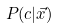Convert formula to latex. <formula><loc_0><loc_0><loc_500><loc_500>P ( c | \vec { x } )</formula> 